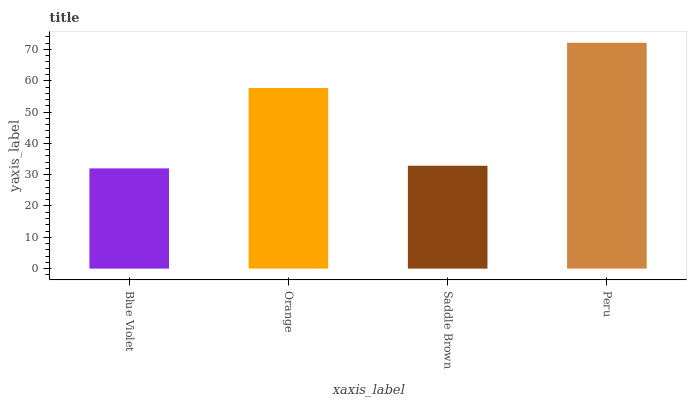Is Blue Violet the minimum?
Answer yes or no. Yes. Is Peru the maximum?
Answer yes or no. Yes. Is Orange the minimum?
Answer yes or no. No. Is Orange the maximum?
Answer yes or no. No. Is Orange greater than Blue Violet?
Answer yes or no. Yes. Is Blue Violet less than Orange?
Answer yes or no. Yes. Is Blue Violet greater than Orange?
Answer yes or no. No. Is Orange less than Blue Violet?
Answer yes or no. No. Is Orange the high median?
Answer yes or no. Yes. Is Saddle Brown the low median?
Answer yes or no. Yes. Is Saddle Brown the high median?
Answer yes or no. No. Is Orange the low median?
Answer yes or no. No. 